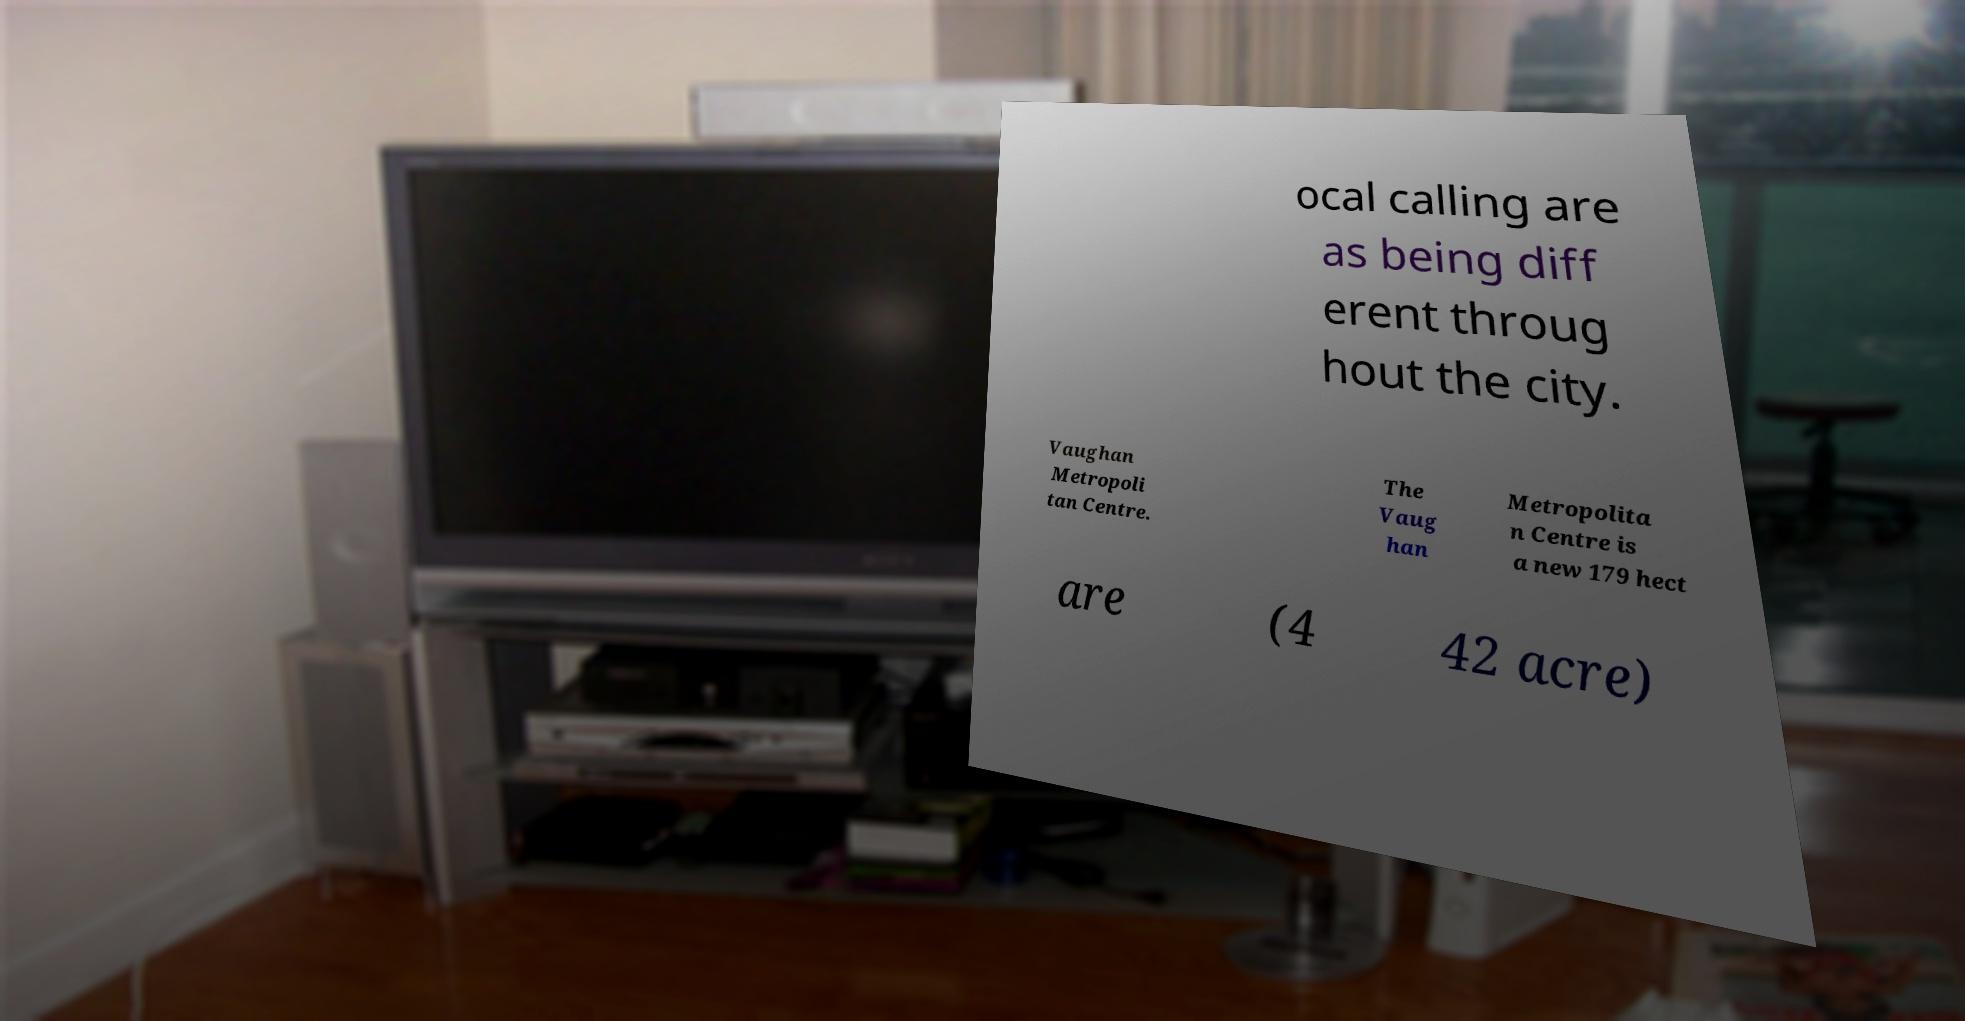What messages or text are displayed in this image? I need them in a readable, typed format. ocal calling are as being diff erent throug hout the city. Vaughan Metropoli tan Centre. The Vaug han Metropolita n Centre is a new 179 hect are (4 42 acre) 